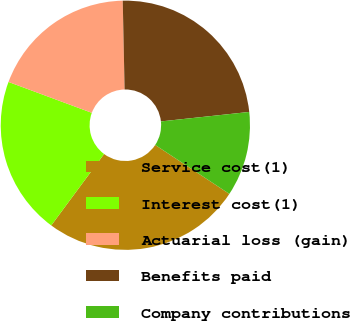Convert chart to OTSL. <chart><loc_0><loc_0><loc_500><loc_500><pie_chart><fcel>Service cost(1)<fcel>Interest cost(1)<fcel>Actuarial loss (gain)<fcel>Benefits paid<fcel>Company contributions<nl><fcel>25.85%<fcel>20.51%<fcel>19.02%<fcel>23.63%<fcel>10.99%<nl></chart> 